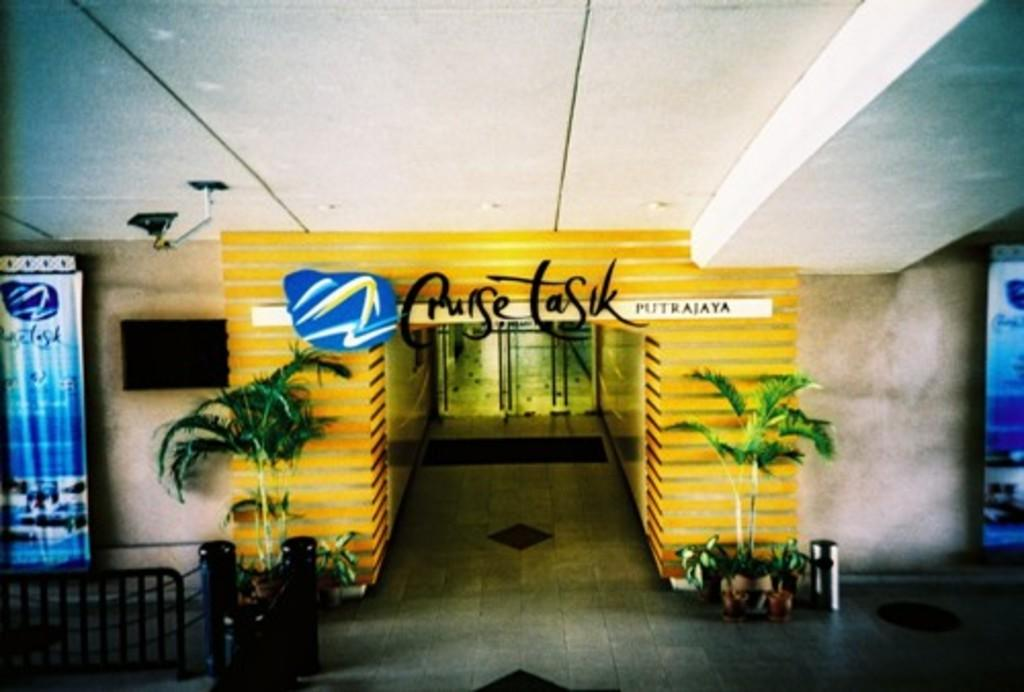Provide a one-sentence caption for the provided image. Cruise Tasuk is in black lettering on a yellow wall. 